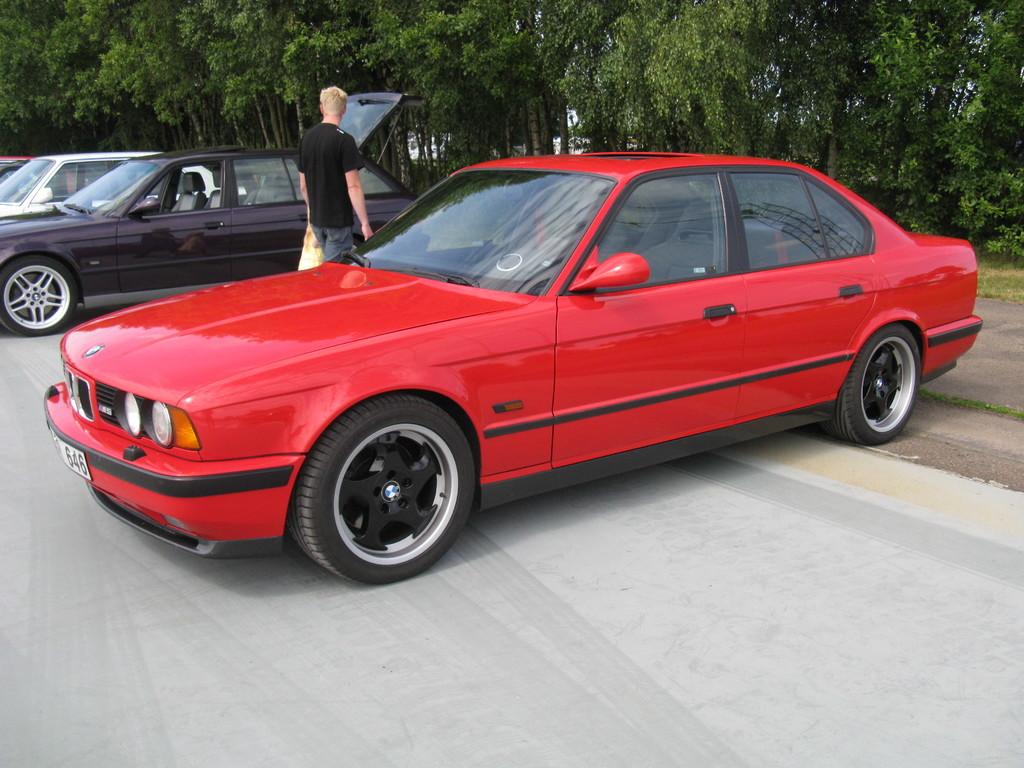What can be seen on the road in the image? There are cars on the road in the image. What is the person standing beside the cars doing? The person is holding a cover. What can be seen in the distance in the image? There are trees visible in the background of the image. What religious teachings are being discussed by the person holding the cover in the image? There is no indication of any religious teachings being discussed in the image. The person is simply holding a cover, and there is no mention of any religious context. 